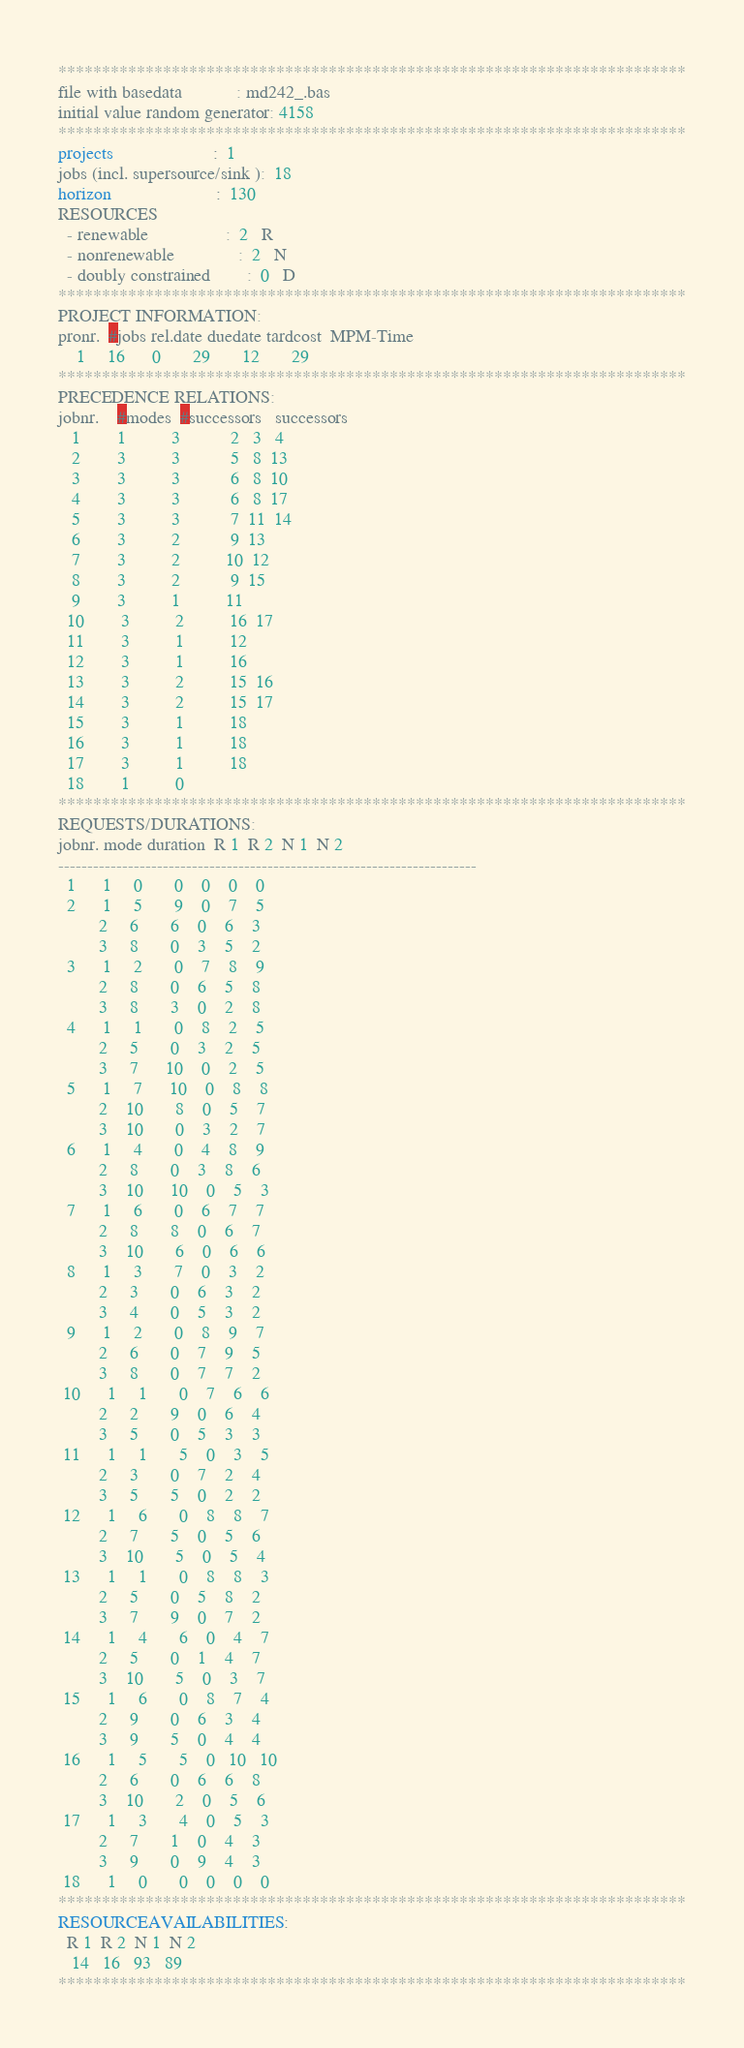Convert code to text. <code><loc_0><loc_0><loc_500><loc_500><_ObjectiveC_>************************************************************************
file with basedata            : md242_.bas
initial value random generator: 4158
************************************************************************
projects                      :  1
jobs (incl. supersource/sink ):  18
horizon                       :  130
RESOURCES
  - renewable                 :  2   R
  - nonrenewable              :  2   N
  - doubly constrained        :  0   D
************************************************************************
PROJECT INFORMATION:
pronr.  #jobs rel.date duedate tardcost  MPM-Time
    1     16      0       29       12       29
************************************************************************
PRECEDENCE RELATIONS:
jobnr.    #modes  #successors   successors
   1        1          3           2   3   4
   2        3          3           5   8  13
   3        3          3           6   8  10
   4        3          3           6   8  17
   5        3          3           7  11  14
   6        3          2           9  13
   7        3          2          10  12
   8        3          2           9  15
   9        3          1          11
  10        3          2          16  17
  11        3          1          12
  12        3          1          16
  13        3          2          15  16
  14        3          2          15  17
  15        3          1          18
  16        3          1          18
  17        3          1          18
  18        1          0        
************************************************************************
REQUESTS/DURATIONS:
jobnr. mode duration  R 1  R 2  N 1  N 2
------------------------------------------------------------------------
  1      1     0       0    0    0    0
  2      1     5       9    0    7    5
         2     6       6    0    6    3
         3     8       0    3    5    2
  3      1     2       0    7    8    9
         2     8       0    6    5    8
         3     8       3    0    2    8
  4      1     1       0    8    2    5
         2     5       0    3    2    5
         3     7      10    0    2    5
  5      1     7      10    0    8    8
         2    10       8    0    5    7
         3    10       0    3    2    7
  6      1     4       0    4    8    9
         2     8       0    3    8    6
         3    10      10    0    5    3
  7      1     6       0    6    7    7
         2     8       8    0    6    7
         3    10       6    0    6    6
  8      1     3       7    0    3    2
         2     3       0    6    3    2
         3     4       0    5    3    2
  9      1     2       0    8    9    7
         2     6       0    7    9    5
         3     8       0    7    7    2
 10      1     1       0    7    6    6
         2     2       9    0    6    4
         3     5       0    5    3    3
 11      1     1       5    0    3    5
         2     3       0    7    2    4
         3     5       5    0    2    2
 12      1     6       0    8    8    7
         2     7       5    0    5    6
         3    10       5    0    5    4
 13      1     1       0    8    8    3
         2     5       0    5    8    2
         3     7       9    0    7    2
 14      1     4       6    0    4    7
         2     5       0    1    4    7
         3    10       5    0    3    7
 15      1     6       0    8    7    4
         2     9       0    6    3    4
         3     9       5    0    4    4
 16      1     5       5    0   10   10
         2     6       0    6    6    8
         3    10       2    0    5    6
 17      1     3       4    0    5    3
         2     7       1    0    4    3
         3     9       0    9    4    3
 18      1     0       0    0    0    0
************************************************************************
RESOURCEAVAILABILITIES:
  R 1  R 2  N 1  N 2
   14   16   93   89
************************************************************************
</code> 